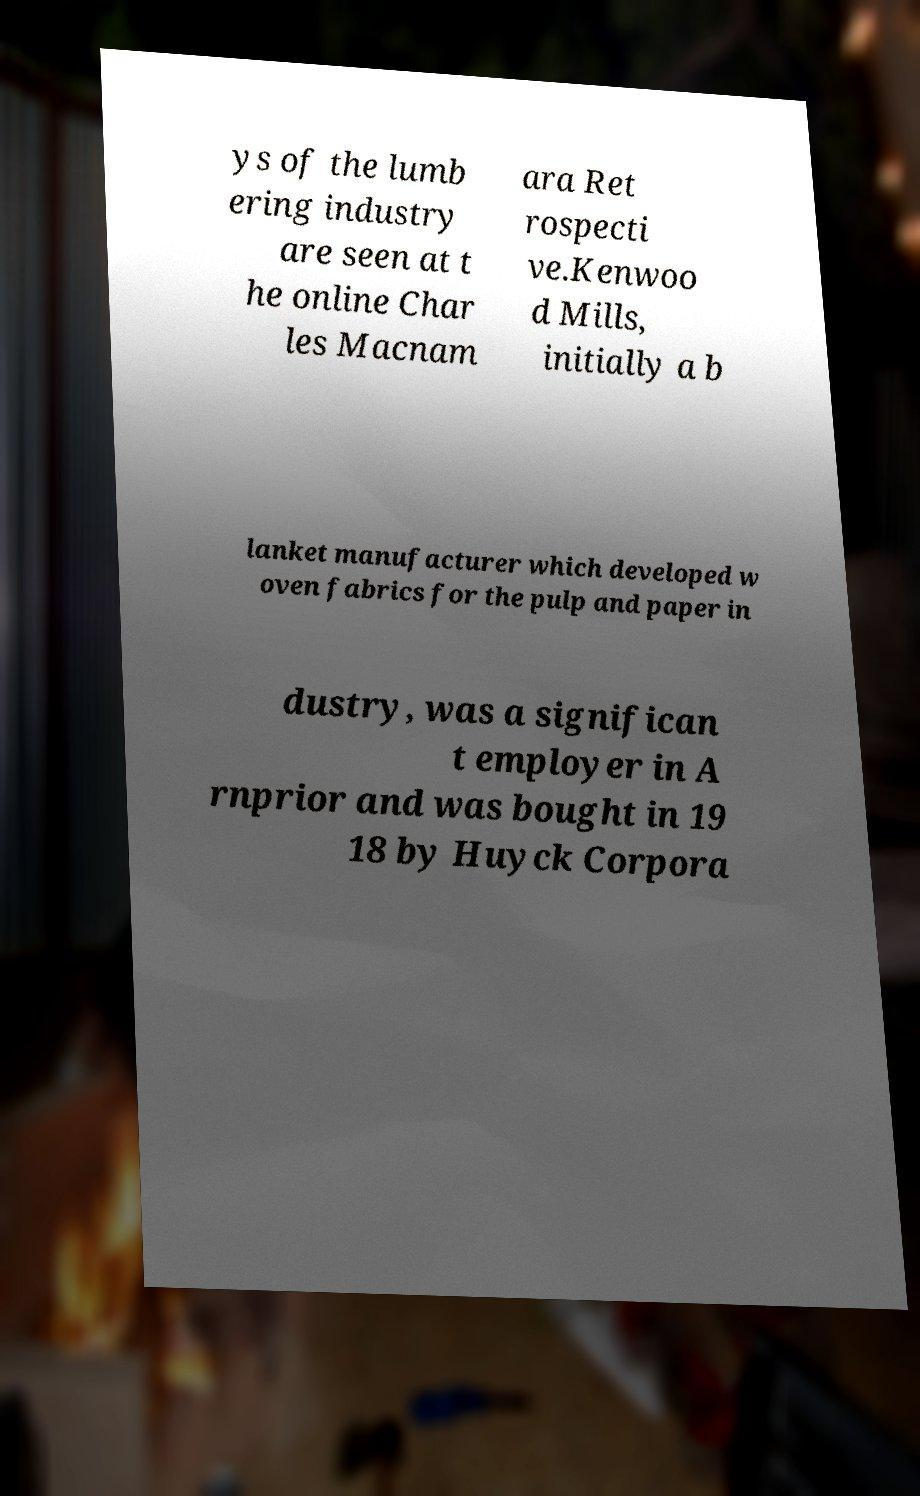What messages or text are displayed in this image? I need them in a readable, typed format. ys of the lumb ering industry are seen at t he online Char les Macnam ara Ret rospecti ve.Kenwoo d Mills, initially a b lanket manufacturer which developed w oven fabrics for the pulp and paper in dustry, was a significan t employer in A rnprior and was bought in 19 18 by Huyck Corpora 